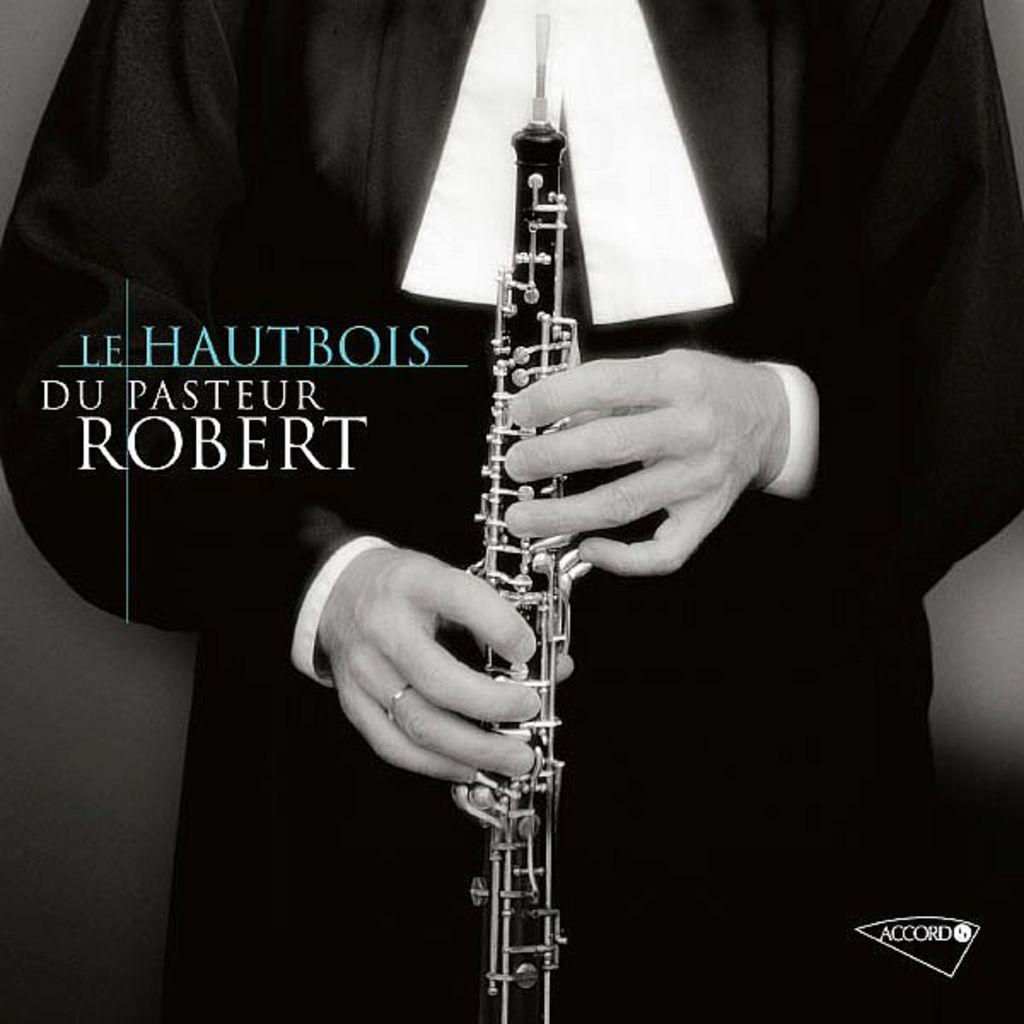What is the main subject of the image? There is a person in the image. What is the person doing in the image? The person is holding a musical instrument. How is the person dressed in the image? The person is wearing a black and white dress. What is the color of the background in the image? The background of the image is black in color. What type of cow can be seen in the image? There is no cow present in the image. What language is the person speaking in the image? The image does not provide any information about the language being spoken. 